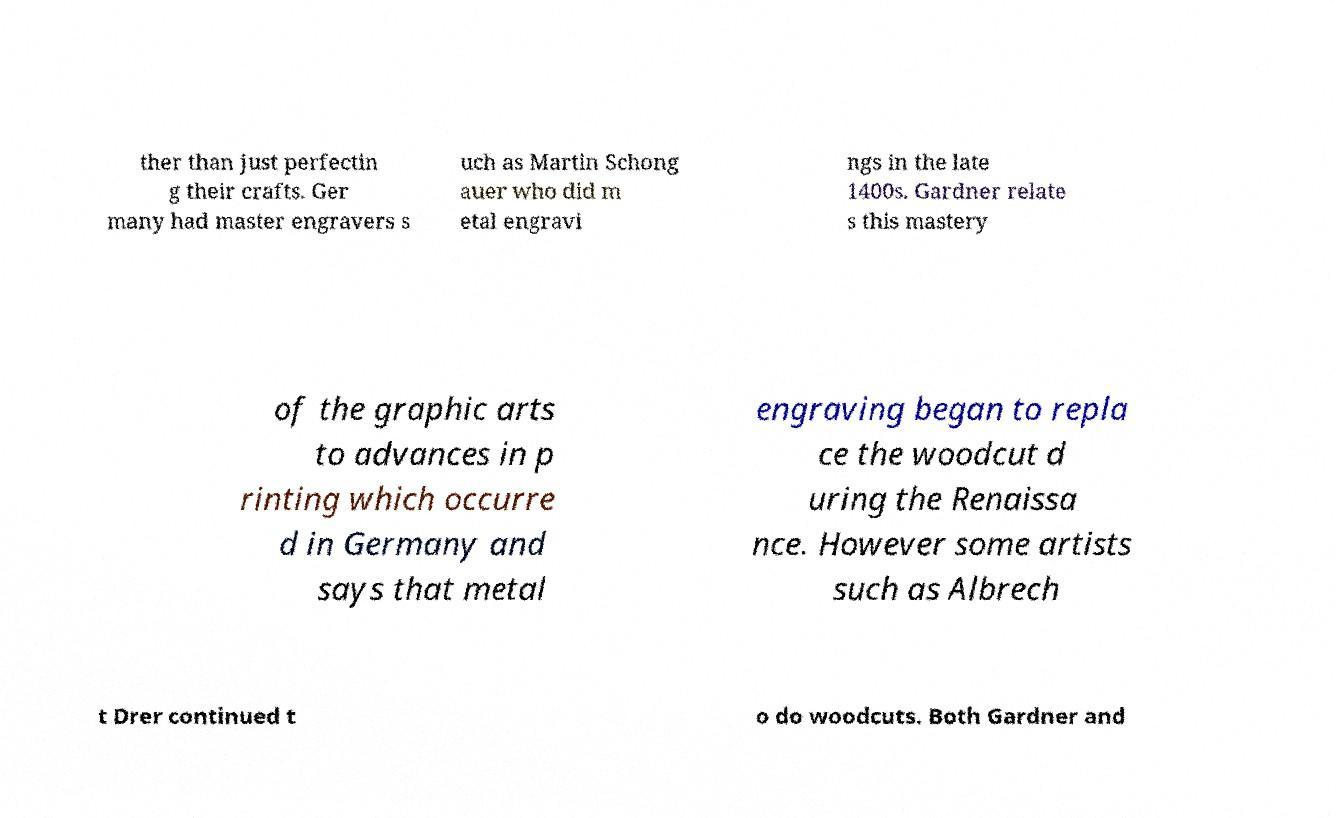Can you read and provide the text displayed in the image?This photo seems to have some interesting text. Can you extract and type it out for me? ther than just perfectin g their crafts. Ger many had master engravers s uch as Martin Schong auer who did m etal engravi ngs in the late 1400s. Gardner relate s this mastery of the graphic arts to advances in p rinting which occurre d in Germany and says that metal engraving began to repla ce the woodcut d uring the Renaissa nce. However some artists such as Albrech t Drer continued t o do woodcuts. Both Gardner and 